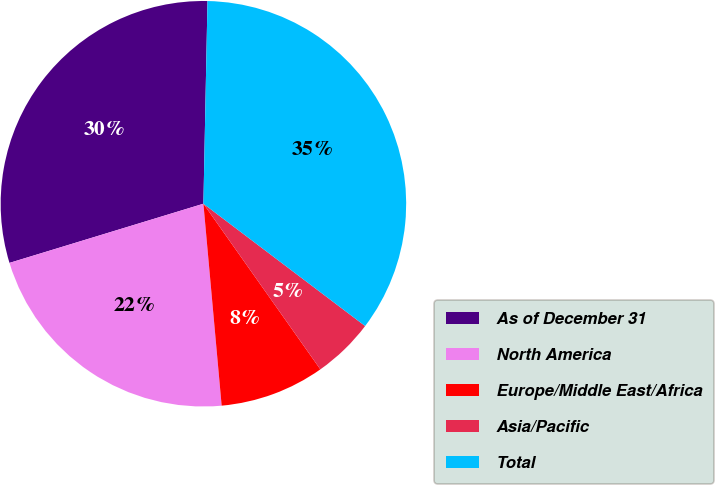<chart> <loc_0><loc_0><loc_500><loc_500><pie_chart><fcel>As of December 31<fcel>North America<fcel>Europe/Middle East/Africa<fcel>Asia/Pacific<fcel>Total<nl><fcel>30.03%<fcel>21.72%<fcel>8.35%<fcel>4.91%<fcel>34.98%<nl></chart> 